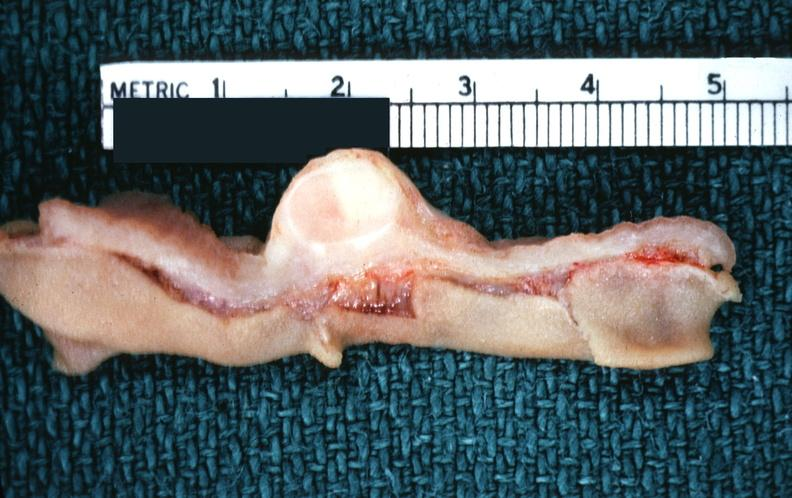s lower chest and abdomen anterior present?
Answer the question using a single word or phrase. No 